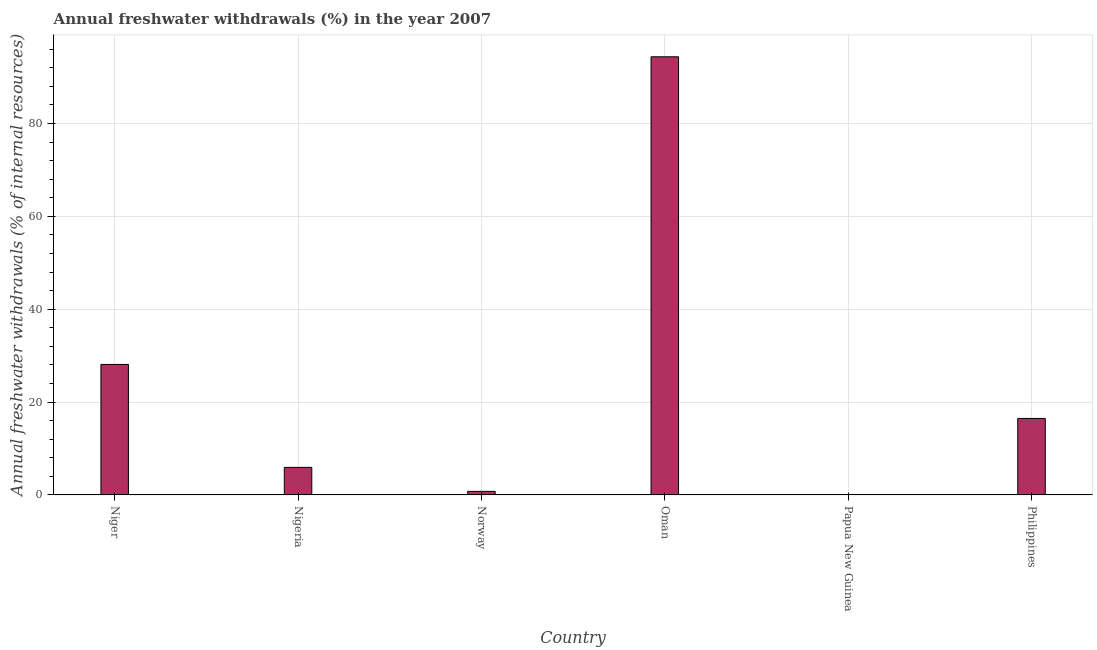Does the graph contain any zero values?
Offer a very short reply. No. What is the title of the graph?
Give a very brief answer. Annual freshwater withdrawals (%) in the year 2007. What is the label or title of the Y-axis?
Keep it short and to the point. Annual freshwater withdrawals (% of internal resources). What is the annual freshwater withdrawals in Oman?
Keep it short and to the point. 94.36. Across all countries, what is the maximum annual freshwater withdrawals?
Provide a short and direct response. 94.36. Across all countries, what is the minimum annual freshwater withdrawals?
Make the answer very short. 0.05. In which country was the annual freshwater withdrawals maximum?
Give a very brief answer. Oman. In which country was the annual freshwater withdrawals minimum?
Your answer should be compact. Papua New Guinea. What is the sum of the annual freshwater withdrawals?
Offer a terse response. 145.68. What is the difference between the annual freshwater withdrawals in Oman and Philippines?
Keep it short and to the point. 77.89. What is the average annual freshwater withdrawals per country?
Give a very brief answer. 24.28. What is the median annual freshwater withdrawals?
Provide a succinct answer. 11.2. In how many countries, is the annual freshwater withdrawals greater than 8 %?
Ensure brevity in your answer.  3. What is the ratio of the annual freshwater withdrawals in Niger to that in Papua New Guinea?
Your answer should be compact. 574.1. Is the annual freshwater withdrawals in Niger less than that in Papua New Guinea?
Keep it short and to the point. No. What is the difference between the highest and the second highest annual freshwater withdrawals?
Keep it short and to the point. 66.25. What is the difference between the highest and the lowest annual freshwater withdrawals?
Ensure brevity in your answer.  94.31. How many bars are there?
Offer a very short reply. 6. Are all the bars in the graph horizontal?
Offer a very short reply. No. What is the Annual freshwater withdrawals (% of internal resources) in Niger?
Your answer should be very brief. 28.1. What is the Annual freshwater withdrawals (% of internal resources) of Nigeria?
Your answer should be very brief. 5.93. What is the Annual freshwater withdrawals (% of internal resources) of Norway?
Your response must be concise. 0.77. What is the Annual freshwater withdrawals (% of internal resources) of Oman?
Provide a succinct answer. 94.36. What is the Annual freshwater withdrawals (% of internal resources) of Papua New Guinea?
Your response must be concise. 0.05. What is the Annual freshwater withdrawals (% of internal resources) of Philippines?
Keep it short and to the point. 16.47. What is the difference between the Annual freshwater withdrawals (% of internal resources) in Niger and Nigeria?
Your response must be concise. 22.17. What is the difference between the Annual freshwater withdrawals (% of internal resources) in Niger and Norway?
Keep it short and to the point. 27.33. What is the difference between the Annual freshwater withdrawals (% of internal resources) in Niger and Oman?
Offer a terse response. -66.25. What is the difference between the Annual freshwater withdrawals (% of internal resources) in Niger and Papua New Guinea?
Keep it short and to the point. 28.05. What is the difference between the Annual freshwater withdrawals (% of internal resources) in Niger and Philippines?
Your answer should be very brief. 11.63. What is the difference between the Annual freshwater withdrawals (% of internal resources) in Nigeria and Norway?
Give a very brief answer. 5.16. What is the difference between the Annual freshwater withdrawals (% of internal resources) in Nigeria and Oman?
Make the answer very short. -88.43. What is the difference between the Annual freshwater withdrawals (% of internal resources) in Nigeria and Papua New Guinea?
Provide a succinct answer. 5.88. What is the difference between the Annual freshwater withdrawals (% of internal resources) in Nigeria and Philippines?
Keep it short and to the point. -10.54. What is the difference between the Annual freshwater withdrawals (% of internal resources) in Norway and Oman?
Keep it short and to the point. -93.59. What is the difference between the Annual freshwater withdrawals (% of internal resources) in Norway and Papua New Guinea?
Keep it short and to the point. 0.72. What is the difference between the Annual freshwater withdrawals (% of internal resources) in Norway and Philippines?
Make the answer very short. -15.7. What is the difference between the Annual freshwater withdrawals (% of internal resources) in Oman and Papua New Guinea?
Keep it short and to the point. 94.31. What is the difference between the Annual freshwater withdrawals (% of internal resources) in Oman and Philippines?
Offer a very short reply. 77.89. What is the difference between the Annual freshwater withdrawals (% of internal resources) in Papua New Guinea and Philippines?
Give a very brief answer. -16.42. What is the ratio of the Annual freshwater withdrawals (% of internal resources) in Niger to that in Nigeria?
Your response must be concise. 4.74. What is the ratio of the Annual freshwater withdrawals (% of internal resources) in Niger to that in Norway?
Your answer should be very brief. 36.53. What is the ratio of the Annual freshwater withdrawals (% of internal resources) in Niger to that in Oman?
Ensure brevity in your answer.  0.3. What is the ratio of the Annual freshwater withdrawals (% of internal resources) in Niger to that in Papua New Guinea?
Make the answer very short. 574.1. What is the ratio of the Annual freshwater withdrawals (% of internal resources) in Niger to that in Philippines?
Make the answer very short. 1.71. What is the ratio of the Annual freshwater withdrawals (% of internal resources) in Nigeria to that in Norway?
Offer a very short reply. 7.71. What is the ratio of the Annual freshwater withdrawals (% of internal resources) in Nigeria to that in Oman?
Your response must be concise. 0.06. What is the ratio of the Annual freshwater withdrawals (% of internal resources) in Nigeria to that in Papua New Guinea?
Provide a succinct answer. 121.18. What is the ratio of the Annual freshwater withdrawals (% of internal resources) in Nigeria to that in Philippines?
Keep it short and to the point. 0.36. What is the ratio of the Annual freshwater withdrawals (% of internal resources) in Norway to that in Oman?
Your answer should be compact. 0.01. What is the ratio of the Annual freshwater withdrawals (% of internal resources) in Norway to that in Papua New Guinea?
Provide a short and direct response. 15.72. What is the ratio of the Annual freshwater withdrawals (% of internal resources) in Norway to that in Philippines?
Provide a succinct answer. 0.05. What is the ratio of the Annual freshwater withdrawals (% of internal resources) in Oman to that in Papua New Guinea?
Offer a very short reply. 1927.57. What is the ratio of the Annual freshwater withdrawals (% of internal resources) in Oman to that in Philippines?
Make the answer very short. 5.73. What is the ratio of the Annual freshwater withdrawals (% of internal resources) in Papua New Guinea to that in Philippines?
Offer a very short reply. 0. 